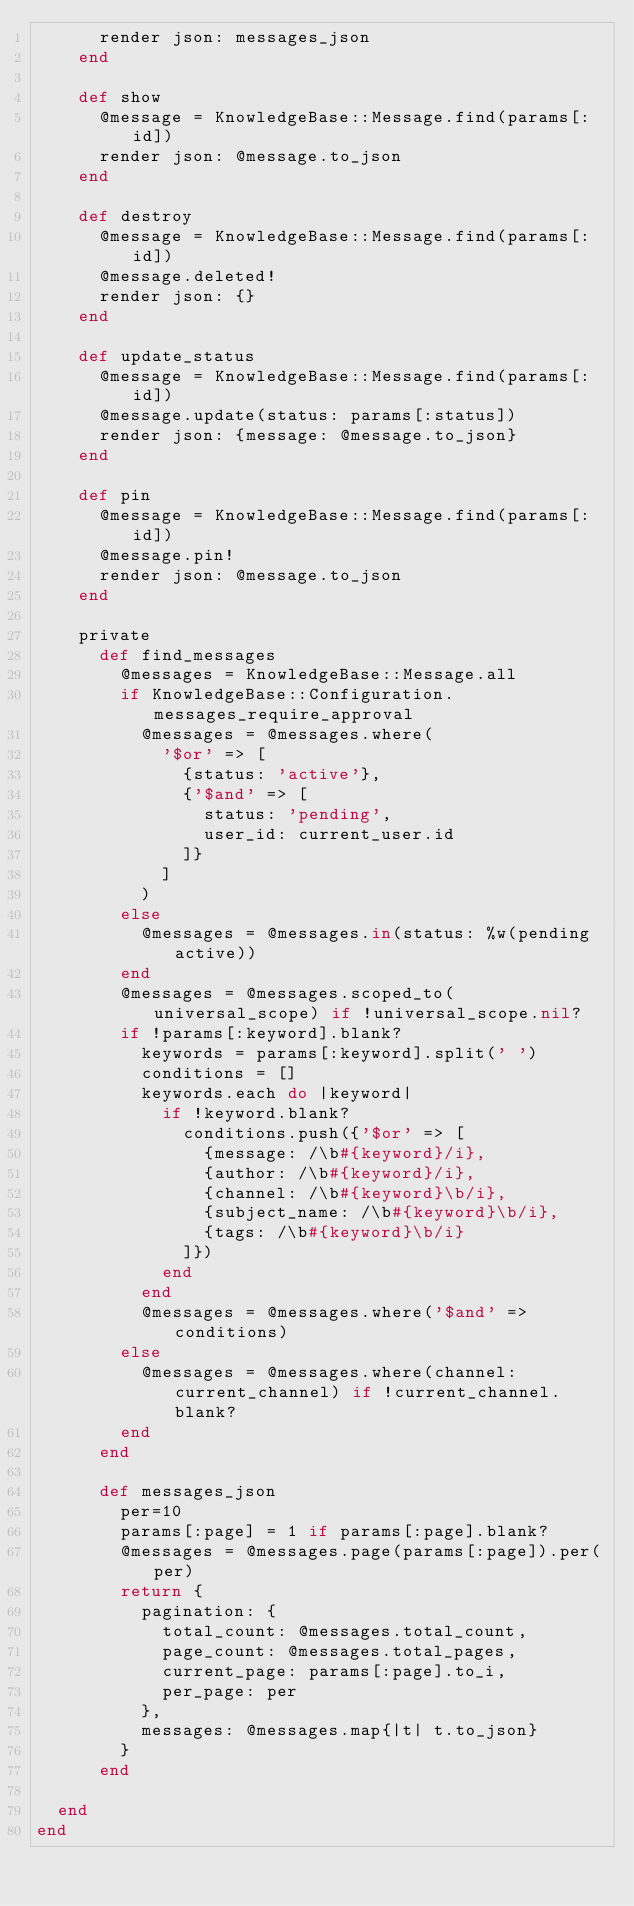Convert code to text. <code><loc_0><loc_0><loc_500><loc_500><_Ruby_>      render json: messages_json
    end
    
    def show
      @message = KnowledgeBase::Message.find(params[:id])
      render json: @message.to_json
    end
    
    def destroy
      @message = KnowledgeBase::Message.find(params[:id])
      @message.deleted!
      render json: {}
    end
    
    def update_status
      @message = KnowledgeBase::Message.find(params[:id])
      @message.update(status: params[:status])
      render json: {message: @message.to_json}
    end
    
    def pin
      @message = KnowledgeBase::Message.find(params[:id])
      @message.pin!
      render json: @message.to_json
    end
    
    private
      def find_messages
        @messages = KnowledgeBase::Message.all
        if KnowledgeBase::Configuration.messages_require_approval
          @messages = @messages.where(
            '$or' => [
              {status: 'active'},
              {'$and' => [
                status: 'pending',
                user_id: current_user.id
              ]}
            ]  
          )
        else
          @messages = @messages.in(status: %w(pending active))
        end
        @messages = @messages.scoped_to(universal_scope) if !universal_scope.nil?
        if !params[:keyword].blank?
          keywords = params[:keyword].split(' ')
          conditions = []
          keywords.each do |keyword|
            if !keyword.blank?
              conditions.push({'$or' => [
                {message: /\b#{keyword}/i}, 
                {author: /\b#{keyword}/i},
                {channel: /\b#{keyword}\b/i},
                {subject_name: /\b#{keyword}\b/i},
                {tags: /\b#{keyword}\b/i}
              ]})
            end
          end
          @messages = @messages.where('$and' => conditions)
        else
          @messages = @messages.where(channel: current_channel) if !current_channel.blank?
        end
      end
    
      def messages_json
        per=10
        params[:page] = 1 if params[:page].blank?
        @messages = @messages.page(params[:page]).per(per)
        return {
          pagination: {
            total_count: @messages.total_count,
            page_count: @messages.total_pages,
            current_page: params[:page].to_i,
            per_page: per
          },
          messages: @messages.map{|t| t.to_json}
        }
      end
      
  end
end
</code> 